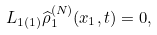<formula> <loc_0><loc_0><loc_500><loc_500>L _ { 1 \left ( 1 \right ) } \widehat { \rho } _ { 1 } ^ { ( N ) } ( x _ { 1 } , t ) = 0 ,</formula> 